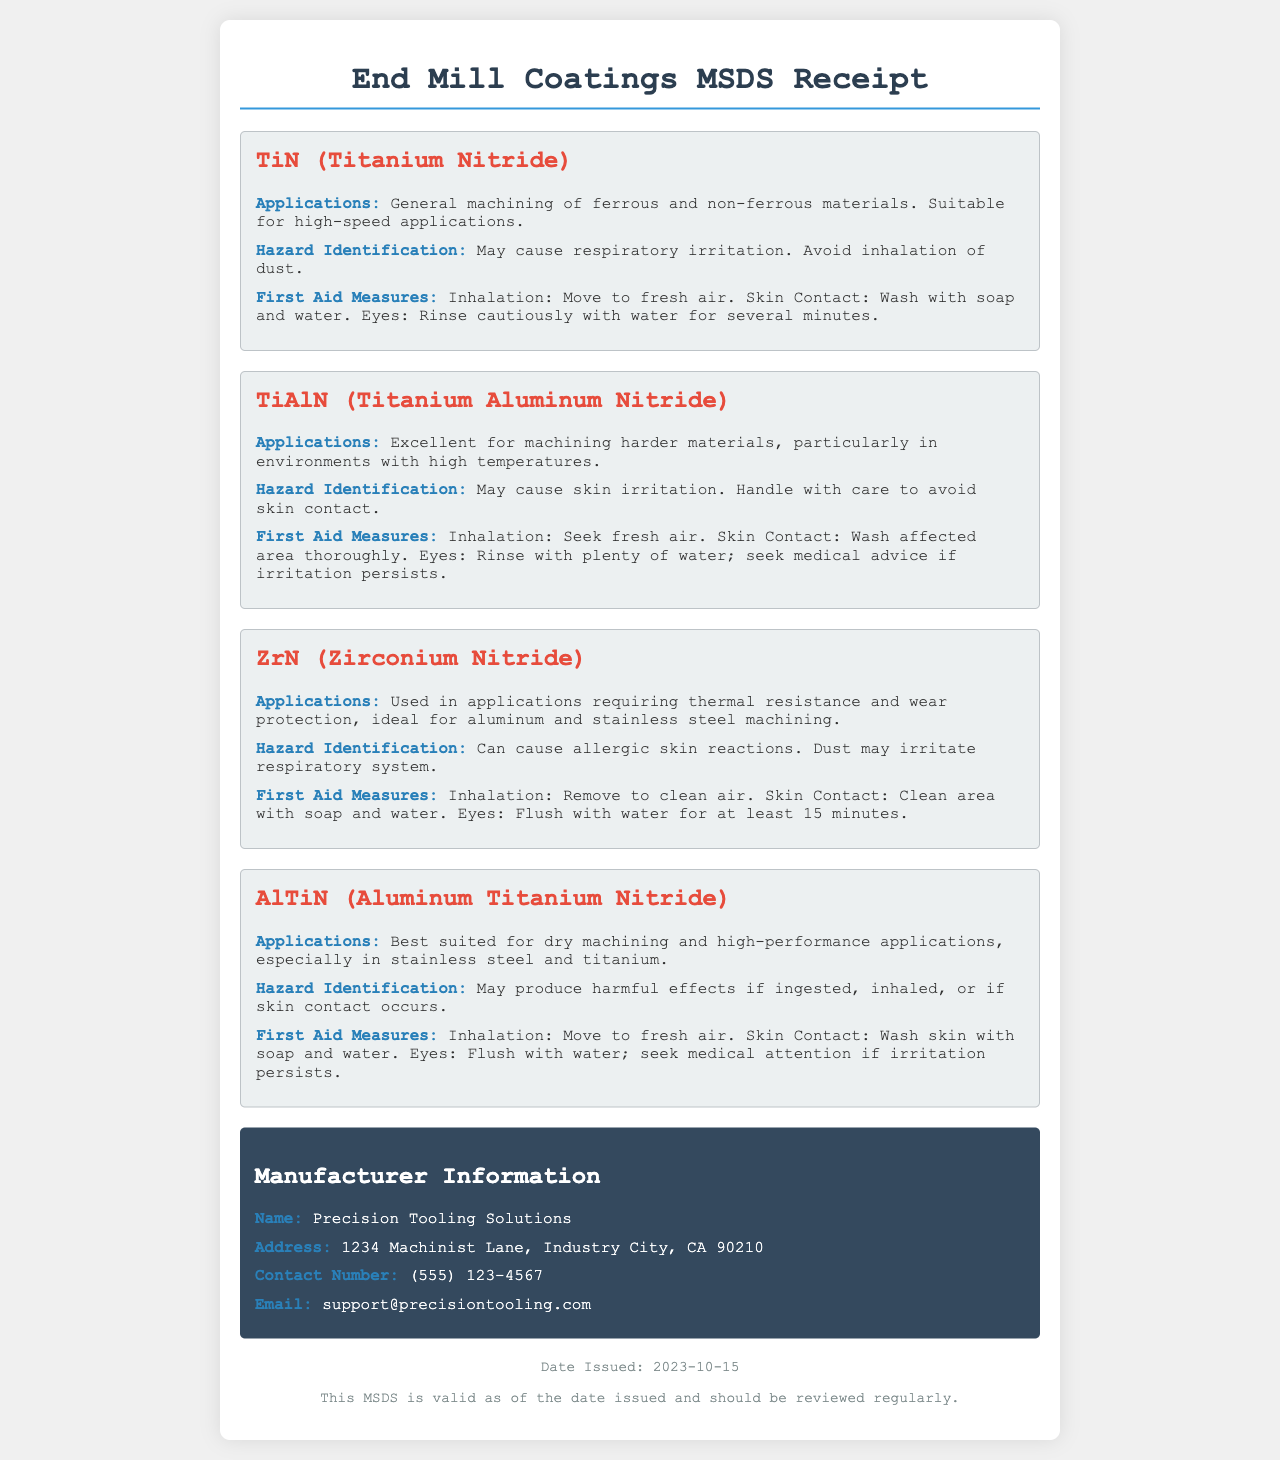what is the name of the first coating listed? The first coating listed in the document is TiN (Titanium Nitride).
Answer: TiN (Titanium Nitride) what are the applications of ZrN? ZrN is used in applications requiring thermal resistance and wear protection, ideal for aluminum and stainless steel machining.
Answer: Thermal resistance and wear protection what is the first aid measure for skin contact with TiAlN? For skin contact with TiAlN, the first aid measure is to wash the affected area thoroughly.
Answer: Wash affected area thoroughly what is the hazard identification for AlTiN? The hazard identification for AlTiN states it may produce harmful effects if ingested, inhaled, or if skin contact occurs.
Answer: May produce harmful effects if ingested, inhaled, or if skin contact occurs who is the manufacturer of the end mill coatings? The manufacturer of the end mill coatings is Precision Tooling Solutions.
Answer: Precision Tooling Solutions what is the contact number for the manufacturer? The contact number for the manufacturer is (555) 123-4567.
Answer: (555) 123-4567 what is the date issued for this MSDS? The document states the date issued for the MSDS is 2023-10-15.
Answer: 2023-10-15 how should dust from TiN be handled? The document advises avoiding inhalation of dust from TiN.
Answer: Avoid inhalation of dust what type of applications is TiAlN best for? TiAlN is best suited for machining harder materials, particularly in high-temperature environments.
Answer: Machining harder materials in high-temperature environments 